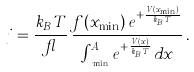<formula> <loc_0><loc_0><loc_500><loc_500>j = \frac { k _ { B } T } { \gamma } \, \frac { f ( x _ { \min } ) \, e ^ { + \frac { V ( x _ { \min } ) } { k _ { B } T } } } { \int ^ { A } _ { x _ { \min } } e ^ { + \frac { V ( x ) } { k _ { B } T } } \, d x } \, .</formula> 